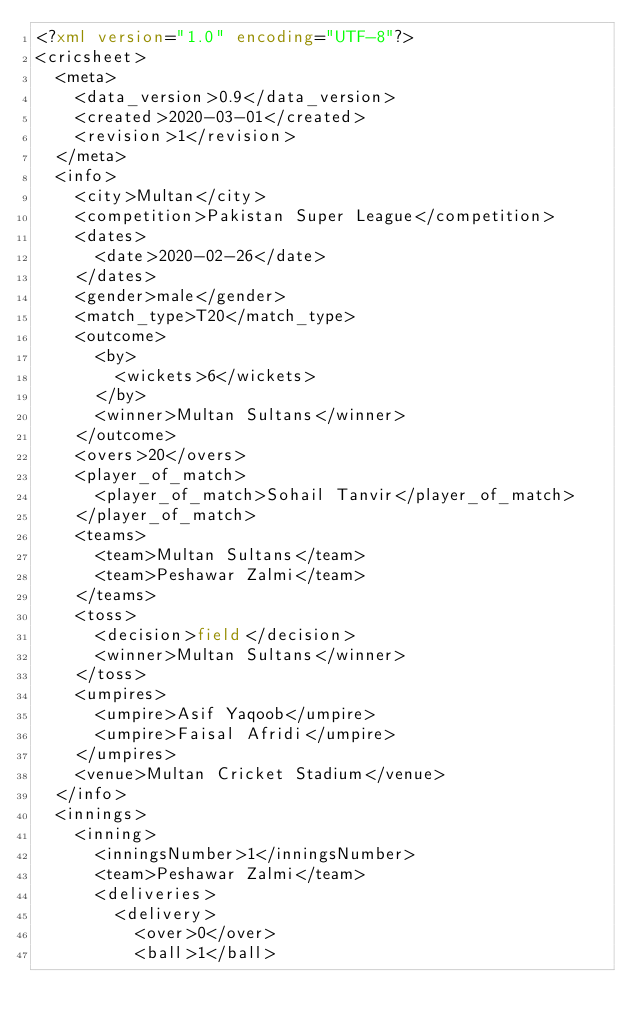Convert code to text. <code><loc_0><loc_0><loc_500><loc_500><_XML_><?xml version="1.0" encoding="UTF-8"?>
<cricsheet>
  <meta>
    <data_version>0.9</data_version>
    <created>2020-03-01</created>
    <revision>1</revision>
  </meta>
  <info>
    <city>Multan</city>
    <competition>Pakistan Super League</competition>
    <dates>
      <date>2020-02-26</date>
    </dates>
    <gender>male</gender>
    <match_type>T20</match_type>
    <outcome>
      <by>
        <wickets>6</wickets>
      </by>
      <winner>Multan Sultans</winner>
    </outcome>
    <overs>20</overs>
    <player_of_match>
      <player_of_match>Sohail Tanvir</player_of_match>
    </player_of_match>
    <teams>
      <team>Multan Sultans</team>
      <team>Peshawar Zalmi</team>
    </teams>
    <toss>
      <decision>field</decision>
      <winner>Multan Sultans</winner>
    </toss>
    <umpires>
      <umpire>Asif Yaqoob</umpire>
      <umpire>Faisal Afridi</umpire>
    </umpires>
    <venue>Multan Cricket Stadium</venue>
  </info>
  <innings>
    <inning>
      <inningsNumber>1</inningsNumber>
      <team>Peshawar Zalmi</team>
      <deliveries>
        <delivery>
          <over>0</over>
          <ball>1</ball></code> 